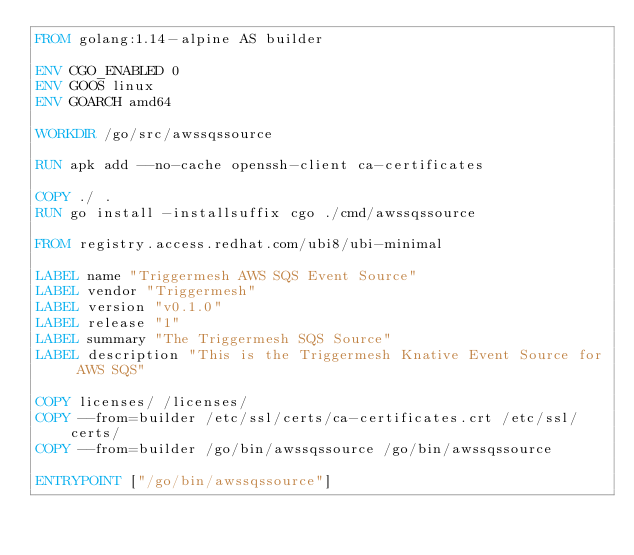Convert code to text. <code><loc_0><loc_0><loc_500><loc_500><_Dockerfile_>FROM golang:1.14-alpine AS builder

ENV CGO_ENABLED 0
ENV GOOS linux
ENV GOARCH amd64

WORKDIR /go/src/awssqssource

RUN apk add --no-cache openssh-client ca-certificates

COPY ./ .
RUN go install -installsuffix cgo ./cmd/awssqssource

FROM registry.access.redhat.com/ubi8/ubi-minimal

LABEL name "Triggermesh AWS SQS Event Source"
LABEL vendor "Triggermesh"
LABEL version "v0.1.0"
LABEL release "1"
LABEL summary "The Triggermesh SQS Source"
LABEL description "This is the Triggermesh Knative Event Source for AWS SQS"

COPY licenses/ /licenses/
COPY --from=builder /etc/ssl/certs/ca-certificates.crt /etc/ssl/certs/
COPY --from=builder /go/bin/awssqssource /go/bin/awssqssource

ENTRYPOINT ["/go/bin/awssqssource"]
</code> 